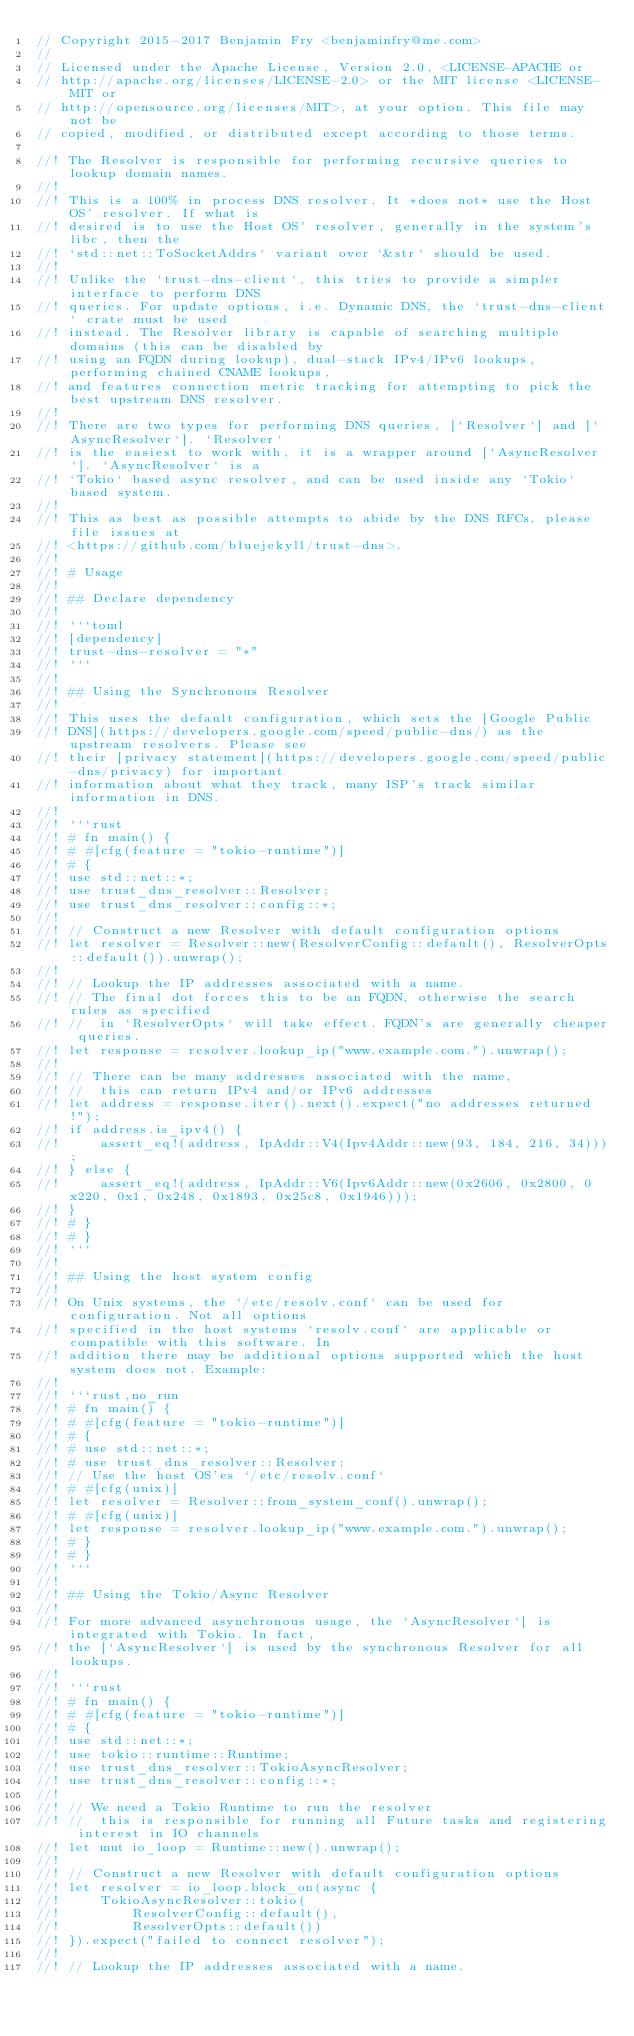Convert code to text. <code><loc_0><loc_0><loc_500><loc_500><_Rust_>// Copyright 2015-2017 Benjamin Fry <benjaminfry@me.com>
//
// Licensed under the Apache License, Version 2.0, <LICENSE-APACHE or
// http://apache.org/licenses/LICENSE-2.0> or the MIT license <LICENSE-MIT or
// http://opensource.org/licenses/MIT>, at your option. This file may not be
// copied, modified, or distributed except according to those terms.

//! The Resolver is responsible for performing recursive queries to lookup domain names.
//!
//! This is a 100% in process DNS resolver. It *does not* use the Host OS' resolver. If what is
//! desired is to use the Host OS' resolver, generally in the system's libc, then the
//! `std::net::ToSocketAddrs` variant over `&str` should be used.
//!
//! Unlike the `trust-dns-client`, this tries to provide a simpler interface to perform DNS
//! queries. For update options, i.e. Dynamic DNS, the `trust-dns-client` crate must be used
//! instead. The Resolver library is capable of searching multiple domains (this can be disabled by
//! using an FQDN during lookup), dual-stack IPv4/IPv6 lookups, performing chained CNAME lookups,
//! and features connection metric tracking for attempting to pick the best upstream DNS resolver.
//!
//! There are two types for performing DNS queries, [`Resolver`] and [`AsyncResolver`]. `Resolver`
//! is the easiest to work with, it is a wrapper around [`AsyncResolver`]. `AsyncResolver` is a
//! `Tokio` based async resolver, and can be used inside any `Tokio` based system.
//!
//! This as best as possible attempts to abide by the DNS RFCs, please file issues at
//! <https://github.com/bluejekyll/trust-dns>.
//!
//! # Usage
//!
//! ## Declare dependency
//!
//! ```toml
//! [dependency]
//! trust-dns-resolver = "*"
//! ```
//!
//! ## Using the Synchronous Resolver
//!
//! This uses the default configuration, which sets the [Google Public
//! DNS](https://developers.google.com/speed/public-dns/) as the upstream resolvers. Please see
//! their [privacy statement](https://developers.google.com/speed/public-dns/privacy) for important
//! information about what they track, many ISP's track similar information in DNS.
//!
//! ```rust
//! # fn main() {
//! # #[cfg(feature = "tokio-runtime")]
//! # {
//! use std::net::*;
//! use trust_dns_resolver::Resolver;
//! use trust_dns_resolver::config::*;
//!
//! // Construct a new Resolver with default configuration options
//! let resolver = Resolver::new(ResolverConfig::default(), ResolverOpts::default()).unwrap();
//!
//! // Lookup the IP addresses associated with a name.
//! // The final dot forces this to be an FQDN, otherwise the search rules as specified
//! //  in `ResolverOpts` will take effect. FQDN's are generally cheaper queries.
//! let response = resolver.lookup_ip("www.example.com.").unwrap();
//!
//! // There can be many addresses associated with the name,
//! //  this can return IPv4 and/or IPv6 addresses
//! let address = response.iter().next().expect("no addresses returned!");
//! if address.is_ipv4() {
//!     assert_eq!(address, IpAddr::V4(Ipv4Addr::new(93, 184, 216, 34)));
//! } else {
//!     assert_eq!(address, IpAddr::V6(Ipv6Addr::new(0x2606, 0x2800, 0x220, 0x1, 0x248, 0x1893, 0x25c8, 0x1946)));
//! }
//! # }
//! # }
//! ```
//!
//! ## Using the host system config
//!
//! On Unix systems, the `/etc/resolv.conf` can be used for configuration. Not all options
//! specified in the host systems `resolv.conf` are applicable or compatible with this software. In
//! addition there may be additional options supported which the host system does not. Example:
//!
//! ```rust,no_run
//! # fn main() {
//! # #[cfg(feature = "tokio-runtime")]
//! # {
//! # use std::net::*;
//! # use trust_dns_resolver::Resolver;
//! // Use the host OS'es `/etc/resolv.conf`
//! # #[cfg(unix)]
//! let resolver = Resolver::from_system_conf().unwrap();
//! # #[cfg(unix)]
//! let response = resolver.lookup_ip("www.example.com.").unwrap();
//! # }
//! # }
//! ```
//!
//! ## Using the Tokio/Async Resolver
//!
//! For more advanced asynchronous usage, the `AsyncResolver`] is integrated with Tokio. In fact,
//! the [`AsyncResolver`] is used by the synchronous Resolver for all lookups.
//!
//! ```rust
//! # fn main() {
//! # #[cfg(feature = "tokio-runtime")]
//! # {
//! use std::net::*;
//! use tokio::runtime::Runtime;
//! use trust_dns_resolver::TokioAsyncResolver;
//! use trust_dns_resolver::config::*;
//!
//! // We need a Tokio Runtime to run the resolver
//! //  this is responsible for running all Future tasks and registering interest in IO channels
//! let mut io_loop = Runtime::new().unwrap();
//!
//! // Construct a new Resolver with default configuration options
//! let resolver = io_loop.block_on(async {
//!     TokioAsyncResolver::tokio(
//!         ResolverConfig::default(),
//!         ResolverOpts::default())
//! }).expect("failed to connect resolver");
//!
//! // Lookup the IP addresses associated with a name.</code> 